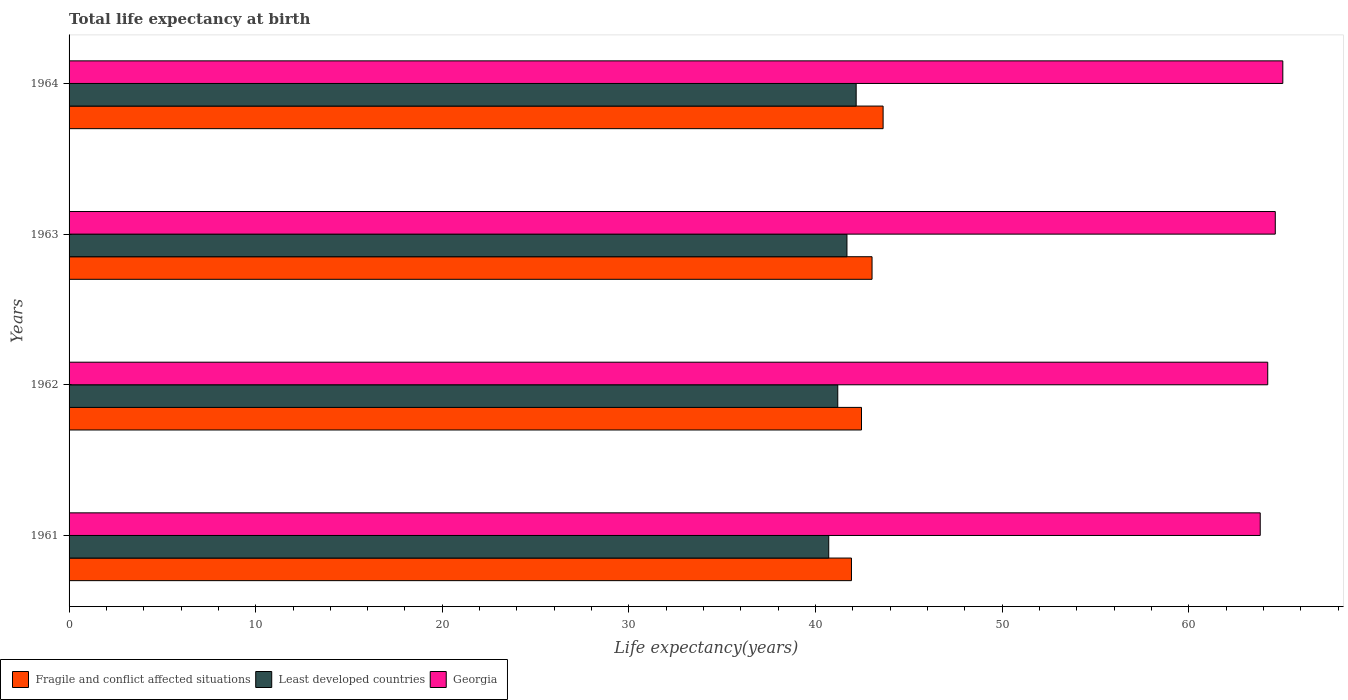How many groups of bars are there?
Give a very brief answer. 4. In how many cases, is the number of bars for a given year not equal to the number of legend labels?
Provide a short and direct response. 0. What is the life expectancy at birth in in Georgia in 1961?
Keep it short and to the point. 63.83. Across all years, what is the maximum life expectancy at birth in in Least developed countries?
Offer a terse response. 42.18. Across all years, what is the minimum life expectancy at birth in in Least developed countries?
Provide a succinct answer. 40.71. In which year was the life expectancy at birth in in Least developed countries maximum?
Offer a very short reply. 1964. In which year was the life expectancy at birth in in Georgia minimum?
Your answer should be compact. 1961. What is the total life expectancy at birth in in Least developed countries in the graph?
Your answer should be very brief. 165.77. What is the difference between the life expectancy at birth in in Least developed countries in 1961 and that in 1962?
Provide a short and direct response. -0.48. What is the difference between the life expectancy at birth in in Least developed countries in 1964 and the life expectancy at birth in in Fragile and conflict affected situations in 1963?
Provide a short and direct response. -0.85. What is the average life expectancy at birth in in Georgia per year?
Your answer should be very brief. 64.44. In the year 1961, what is the difference between the life expectancy at birth in in Fragile and conflict affected situations and life expectancy at birth in in Georgia?
Your response must be concise. -21.9. In how many years, is the life expectancy at birth in in Least developed countries greater than 56 years?
Offer a very short reply. 0. What is the ratio of the life expectancy at birth in in Least developed countries in 1962 to that in 1964?
Your answer should be compact. 0.98. Is the difference between the life expectancy at birth in in Fragile and conflict affected situations in 1961 and 1963 greater than the difference between the life expectancy at birth in in Georgia in 1961 and 1963?
Ensure brevity in your answer.  No. What is the difference between the highest and the second highest life expectancy at birth in in Georgia?
Offer a very short reply. 0.4. What is the difference between the highest and the lowest life expectancy at birth in in Fragile and conflict affected situations?
Provide a short and direct response. 1.7. In how many years, is the life expectancy at birth in in Fragile and conflict affected situations greater than the average life expectancy at birth in in Fragile and conflict affected situations taken over all years?
Your response must be concise. 2. Is the sum of the life expectancy at birth in in Georgia in 1963 and 1964 greater than the maximum life expectancy at birth in in Fragile and conflict affected situations across all years?
Provide a short and direct response. Yes. What does the 2nd bar from the top in 1961 represents?
Ensure brevity in your answer.  Least developed countries. What does the 2nd bar from the bottom in 1962 represents?
Provide a succinct answer. Least developed countries. Are all the bars in the graph horizontal?
Offer a very short reply. Yes. Does the graph contain any zero values?
Ensure brevity in your answer.  No. Does the graph contain grids?
Your answer should be compact. No. Where does the legend appear in the graph?
Keep it short and to the point. Bottom left. What is the title of the graph?
Offer a terse response. Total life expectancy at birth. What is the label or title of the X-axis?
Keep it short and to the point. Life expectancy(years). What is the label or title of the Y-axis?
Ensure brevity in your answer.  Years. What is the Life expectancy(years) of Fragile and conflict affected situations in 1961?
Provide a succinct answer. 41.93. What is the Life expectancy(years) of Least developed countries in 1961?
Provide a short and direct response. 40.71. What is the Life expectancy(years) in Georgia in 1961?
Your answer should be compact. 63.83. What is the Life expectancy(years) in Fragile and conflict affected situations in 1962?
Your answer should be compact. 42.47. What is the Life expectancy(years) in Least developed countries in 1962?
Offer a terse response. 41.19. What is the Life expectancy(years) in Georgia in 1962?
Provide a short and direct response. 64.23. What is the Life expectancy(years) of Fragile and conflict affected situations in 1963?
Your answer should be very brief. 43.03. What is the Life expectancy(years) in Least developed countries in 1963?
Provide a short and direct response. 41.68. What is the Life expectancy(years) of Georgia in 1963?
Ensure brevity in your answer.  64.64. What is the Life expectancy(years) of Fragile and conflict affected situations in 1964?
Ensure brevity in your answer.  43.62. What is the Life expectancy(years) in Least developed countries in 1964?
Your answer should be compact. 42.18. What is the Life expectancy(years) in Georgia in 1964?
Provide a succinct answer. 65.04. Across all years, what is the maximum Life expectancy(years) of Fragile and conflict affected situations?
Provide a short and direct response. 43.62. Across all years, what is the maximum Life expectancy(years) in Least developed countries?
Give a very brief answer. 42.18. Across all years, what is the maximum Life expectancy(years) of Georgia?
Offer a very short reply. 65.04. Across all years, what is the minimum Life expectancy(years) in Fragile and conflict affected situations?
Keep it short and to the point. 41.93. Across all years, what is the minimum Life expectancy(years) of Least developed countries?
Your answer should be compact. 40.71. Across all years, what is the minimum Life expectancy(years) in Georgia?
Give a very brief answer. 63.83. What is the total Life expectancy(years) in Fragile and conflict affected situations in the graph?
Ensure brevity in your answer.  171.05. What is the total Life expectancy(years) in Least developed countries in the graph?
Your answer should be compact. 165.77. What is the total Life expectancy(years) in Georgia in the graph?
Ensure brevity in your answer.  257.75. What is the difference between the Life expectancy(years) of Fragile and conflict affected situations in 1961 and that in 1962?
Offer a very short reply. -0.54. What is the difference between the Life expectancy(years) in Least developed countries in 1961 and that in 1962?
Your answer should be very brief. -0.48. What is the difference between the Life expectancy(years) in Georgia in 1961 and that in 1962?
Give a very brief answer. -0.4. What is the difference between the Life expectancy(years) of Fragile and conflict affected situations in 1961 and that in 1963?
Offer a terse response. -1.1. What is the difference between the Life expectancy(years) of Least developed countries in 1961 and that in 1963?
Ensure brevity in your answer.  -0.98. What is the difference between the Life expectancy(years) of Georgia in 1961 and that in 1963?
Provide a short and direct response. -0.81. What is the difference between the Life expectancy(years) in Fragile and conflict affected situations in 1961 and that in 1964?
Provide a succinct answer. -1.7. What is the difference between the Life expectancy(years) in Least developed countries in 1961 and that in 1964?
Provide a succinct answer. -1.47. What is the difference between the Life expectancy(years) in Georgia in 1961 and that in 1964?
Offer a very short reply. -1.21. What is the difference between the Life expectancy(years) of Fragile and conflict affected situations in 1962 and that in 1963?
Provide a succinct answer. -0.57. What is the difference between the Life expectancy(years) in Least developed countries in 1962 and that in 1963?
Give a very brief answer. -0.49. What is the difference between the Life expectancy(years) in Georgia in 1962 and that in 1963?
Offer a very short reply. -0.4. What is the difference between the Life expectancy(years) in Fragile and conflict affected situations in 1962 and that in 1964?
Your response must be concise. -1.16. What is the difference between the Life expectancy(years) in Least developed countries in 1962 and that in 1964?
Your answer should be compact. -0.99. What is the difference between the Life expectancy(years) in Georgia in 1962 and that in 1964?
Provide a short and direct response. -0.81. What is the difference between the Life expectancy(years) of Fragile and conflict affected situations in 1963 and that in 1964?
Your answer should be very brief. -0.59. What is the difference between the Life expectancy(years) in Least developed countries in 1963 and that in 1964?
Give a very brief answer. -0.49. What is the difference between the Life expectancy(years) in Georgia in 1963 and that in 1964?
Your response must be concise. -0.4. What is the difference between the Life expectancy(years) in Fragile and conflict affected situations in 1961 and the Life expectancy(years) in Least developed countries in 1962?
Offer a terse response. 0.73. What is the difference between the Life expectancy(years) of Fragile and conflict affected situations in 1961 and the Life expectancy(years) of Georgia in 1962?
Keep it short and to the point. -22.31. What is the difference between the Life expectancy(years) of Least developed countries in 1961 and the Life expectancy(years) of Georgia in 1962?
Your answer should be very brief. -23.53. What is the difference between the Life expectancy(years) of Fragile and conflict affected situations in 1961 and the Life expectancy(years) of Least developed countries in 1963?
Offer a very short reply. 0.24. What is the difference between the Life expectancy(years) in Fragile and conflict affected situations in 1961 and the Life expectancy(years) in Georgia in 1963?
Offer a very short reply. -22.71. What is the difference between the Life expectancy(years) of Least developed countries in 1961 and the Life expectancy(years) of Georgia in 1963?
Offer a very short reply. -23.93. What is the difference between the Life expectancy(years) in Fragile and conflict affected situations in 1961 and the Life expectancy(years) in Least developed countries in 1964?
Give a very brief answer. -0.25. What is the difference between the Life expectancy(years) of Fragile and conflict affected situations in 1961 and the Life expectancy(years) of Georgia in 1964?
Your response must be concise. -23.11. What is the difference between the Life expectancy(years) of Least developed countries in 1961 and the Life expectancy(years) of Georgia in 1964?
Make the answer very short. -24.33. What is the difference between the Life expectancy(years) in Fragile and conflict affected situations in 1962 and the Life expectancy(years) in Least developed countries in 1963?
Provide a short and direct response. 0.78. What is the difference between the Life expectancy(years) in Fragile and conflict affected situations in 1962 and the Life expectancy(years) in Georgia in 1963?
Your answer should be compact. -22.17. What is the difference between the Life expectancy(years) of Least developed countries in 1962 and the Life expectancy(years) of Georgia in 1963?
Your answer should be compact. -23.45. What is the difference between the Life expectancy(years) in Fragile and conflict affected situations in 1962 and the Life expectancy(years) in Least developed countries in 1964?
Your answer should be very brief. 0.29. What is the difference between the Life expectancy(years) in Fragile and conflict affected situations in 1962 and the Life expectancy(years) in Georgia in 1964?
Offer a terse response. -22.58. What is the difference between the Life expectancy(years) of Least developed countries in 1962 and the Life expectancy(years) of Georgia in 1964?
Provide a succinct answer. -23.85. What is the difference between the Life expectancy(years) of Fragile and conflict affected situations in 1963 and the Life expectancy(years) of Least developed countries in 1964?
Provide a succinct answer. 0.85. What is the difference between the Life expectancy(years) in Fragile and conflict affected situations in 1963 and the Life expectancy(years) in Georgia in 1964?
Provide a succinct answer. -22.01. What is the difference between the Life expectancy(years) in Least developed countries in 1963 and the Life expectancy(years) in Georgia in 1964?
Offer a very short reply. -23.36. What is the average Life expectancy(years) in Fragile and conflict affected situations per year?
Ensure brevity in your answer.  42.76. What is the average Life expectancy(years) in Least developed countries per year?
Give a very brief answer. 41.44. What is the average Life expectancy(years) in Georgia per year?
Offer a terse response. 64.44. In the year 1961, what is the difference between the Life expectancy(years) in Fragile and conflict affected situations and Life expectancy(years) in Least developed countries?
Your answer should be compact. 1.22. In the year 1961, what is the difference between the Life expectancy(years) of Fragile and conflict affected situations and Life expectancy(years) of Georgia?
Offer a terse response. -21.9. In the year 1961, what is the difference between the Life expectancy(years) of Least developed countries and Life expectancy(years) of Georgia?
Offer a very short reply. -23.12. In the year 1962, what is the difference between the Life expectancy(years) in Fragile and conflict affected situations and Life expectancy(years) in Least developed countries?
Offer a terse response. 1.27. In the year 1962, what is the difference between the Life expectancy(years) in Fragile and conflict affected situations and Life expectancy(years) in Georgia?
Your answer should be very brief. -21.77. In the year 1962, what is the difference between the Life expectancy(years) in Least developed countries and Life expectancy(years) in Georgia?
Offer a terse response. -23.04. In the year 1963, what is the difference between the Life expectancy(years) of Fragile and conflict affected situations and Life expectancy(years) of Least developed countries?
Your answer should be very brief. 1.35. In the year 1963, what is the difference between the Life expectancy(years) in Fragile and conflict affected situations and Life expectancy(years) in Georgia?
Provide a short and direct response. -21.61. In the year 1963, what is the difference between the Life expectancy(years) in Least developed countries and Life expectancy(years) in Georgia?
Provide a succinct answer. -22.95. In the year 1964, what is the difference between the Life expectancy(years) in Fragile and conflict affected situations and Life expectancy(years) in Least developed countries?
Provide a short and direct response. 1.44. In the year 1964, what is the difference between the Life expectancy(years) of Fragile and conflict affected situations and Life expectancy(years) of Georgia?
Provide a short and direct response. -21.42. In the year 1964, what is the difference between the Life expectancy(years) of Least developed countries and Life expectancy(years) of Georgia?
Keep it short and to the point. -22.86. What is the ratio of the Life expectancy(years) in Fragile and conflict affected situations in 1961 to that in 1962?
Provide a short and direct response. 0.99. What is the ratio of the Life expectancy(years) of Least developed countries in 1961 to that in 1962?
Your answer should be compact. 0.99. What is the ratio of the Life expectancy(years) in Georgia in 1961 to that in 1962?
Offer a very short reply. 0.99. What is the ratio of the Life expectancy(years) of Fragile and conflict affected situations in 1961 to that in 1963?
Offer a terse response. 0.97. What is the ratio of the Life expectancy(years) of Least developed countries in 1961 to that in 1963?
Provide a succinct answer. 0.98. What is the ratio of the Life expectancy(years) in Georgia in 1961 to that in 1963?
Provide a short and direct response. 0.99. What is the ratio of the Life expectancy(years) of Fragile and conflict affected situations in 1961 to that in 1964?
Ensure brevity in your answer.  0.96. What is the ratio of the Life expectancy(years) in Least developed countries in 1961 to that in 1964?
Offer a terse response. 0.97. What is the ratio of the Life expectancy(years) of Georgia in 1961 to that in 1964?
Offer a terse response. 0.98. What is the ratio of the Life expectancy(years) of Fragile and conflict affected situations in 1962 to that in 1963?
Ensure brevity in your answer.  0.99. What is the ratio of the Life expectancy(years) of Least developed countries in 1962 to that in 1963?
Provide a succinct answer. 0.99. What is the ratio of the Life expectancy(years) of Fragile and conflict affected situations in 1962 to that in 1964?
Make the answer very short. 0.97. What is the ratio of the Life expectancy(years) of Least developed countries in 1962 to that in 1964?
Your answer should be compact. 0.98. What is the ratio of the Life expectancy(years) in Georgia in 1962 to that in 1964?
Give a very brief answer. 0.99. What is the ratio of the Life expectancy(years) of Fragile and conflict affected situations in 1963 to that in 1964?
Your response must be concise. 0.99. What is the ratio of the Life expectancy(years) in Least developed countries in 1963 to that in 1964?
Provide a succinct answer. 0.99. What is the ratio of the Life expectancy(years) in Georgia in 1963 to that in 1964?
Provide a succinct answer. 0.99. What is the difference between the highest and the second highest Life expectancy(years) in Fragile and conflict affected situations?
Offer a very short reply. 0.59. What is the difference between the highest and the second highest Life expectancy(years) in Least developed countries?
Your answer should be compact. 0.49. What is the difference between the highest and the second highest Life expectancy(years) of Georgia?
Offer a very short reply. 0.4. What is the difference between the highest and the lowest Life expectancy(years) of Fragile and conflict affected situations?
Your answer should be compact. 1.7. What is the difference between the highest and the lowest Life expectancy(years) in Least developed countries?
Provide a succinct answer. 1.47. What is the difference between the highest and the lowest Life expectancy(years) in Georgia?
Keep it short and to the point. 1.21. 